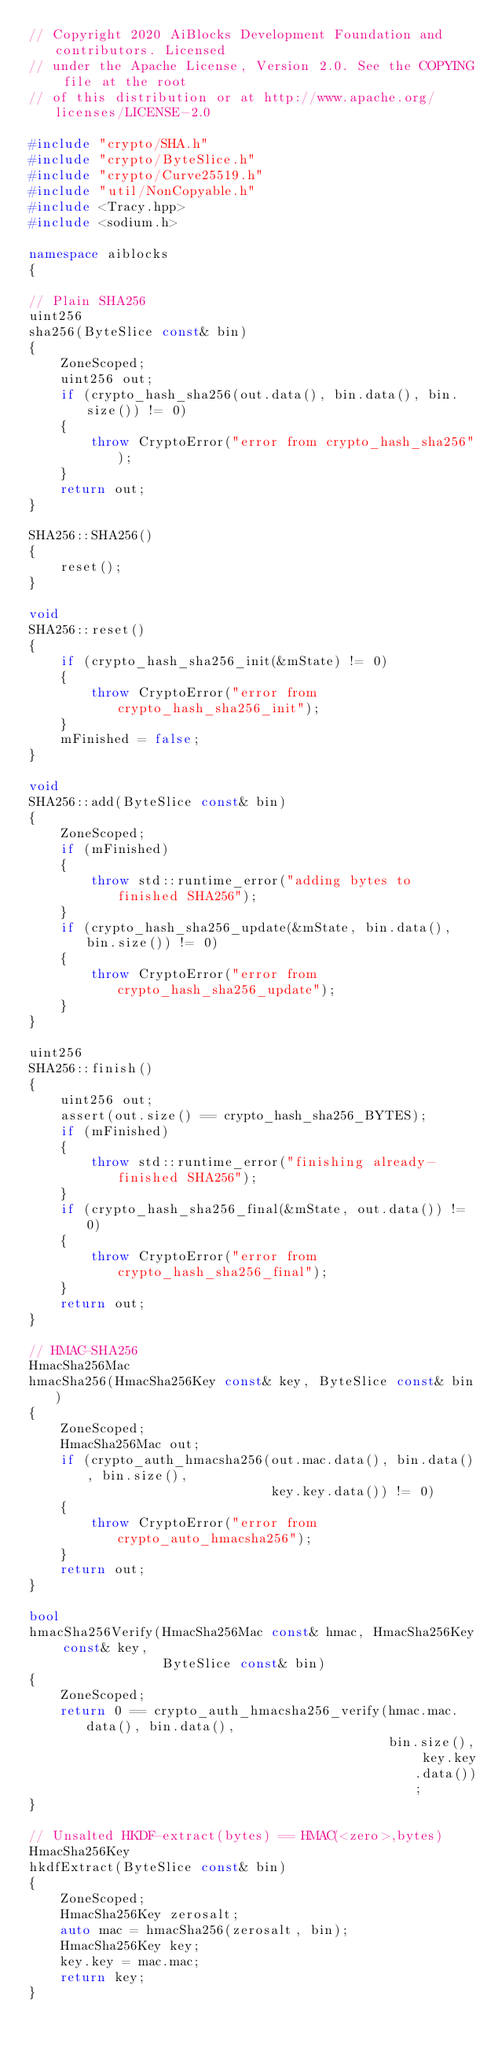Convert code to text. <code><loc_0><loc_0><loc_500><loc_500><_C++_>// Copyright 2020 AiBlocks Development Foundation and contributors. Licensed
// under the Apache License, Version 2.0. See the COPYING file at the root
// of this distribution or at http://www.apache.org/licenses/LICENSE-2.0

#include "crypto/SHA.h"
#include "crypto/ByteSlice.h"
#include "crypto/Curve25519.h"
#include "util/NonCopyable.h"
#include <Tracy.hpp>
#include <sodium.h>

namespace aiblocks
{

// Plain SHA256
uint256
sha256(ByteSlice const& bin)
{
    ZoneScoped;
    uint256 out;
    if (crypto_hash_sha256(out.data(), bin.data(), bin.size()) != 0)
    {
        throw CryptoError("error from crypto_hash_sha256");
    }
    return out;
}

SHA256::SHA256()
{
    reset();
}

void
SHA256::reset()
{
    if (crypto_hash_sha256_init(&mState) != 0)
    {
        throw CryptoError("error from crypto_hash_sha256_init");
    }
    mFinished = false;
}

void
SHA256::add(ByteSlice const& bin)
{
    ZoneScoped;
    if (mFinished)
    {
        throw std::runtime_error("adding bytes to finished SHA256");
    }
    if (crypto_hash_sha256_update(&mState, bin.data(), bin.size()) != 0)
    {
        throw CryptoError("error from crypto_hash_sha256_update");
    }
}

uint256
SHA256::finish()
{
    uint256 out;
    assert(out.size() == crypto_hash_sha256_BYTES);
    if (mFinished)
    {
        throw std::runtime_error("finishing already-finished SHA256");
    }
    if (crypto_hash_sha256_final(&mState, out.data()) != 0)
    {
        throw CryptoError("error from crypto_hash_sha256_final");
    }
    return out;
}

// HMAC-SHA256
HmacSha256Mac
hmacSha256(HmacSha256Key const& key, ByteSlice const& bin)
{
    ZoneScoped;
    HmacSha256Mac out;
    if (crypto_auth_hmacsha256(out.mac.data(), bin.data(), bin.size(),
                               key.key.data()) != 0)
    {
        throw CryptoError("error from crypto_auto_hmacsha256");
    }
    return out;
}

bool
hmacSha256Verify(HmacSha256Mac const& hmac, HmacSha256Key const& key,
                 ByteSlice const& bin)
{
    ZoneScoped;
    return 0 == crypto_auth_hmacsha256_verify(hmac.mac.data(), bin.data(),
                                              bin.size(), key.key.data());
}

// Unsalted HKDF-extract(bytes) == HMAC(<zero>,bytes)
HmacSha256Key
hkdfExtract(ByteSlice const& bin)
{
    ZoneScoped;
    HmacSha256Key zerosalt;
    auto mac = hmacSha256(zerosalt, bin);
    HmacSha256Key key;
    key.key = mac.mac;
    return key;
}
</code> 